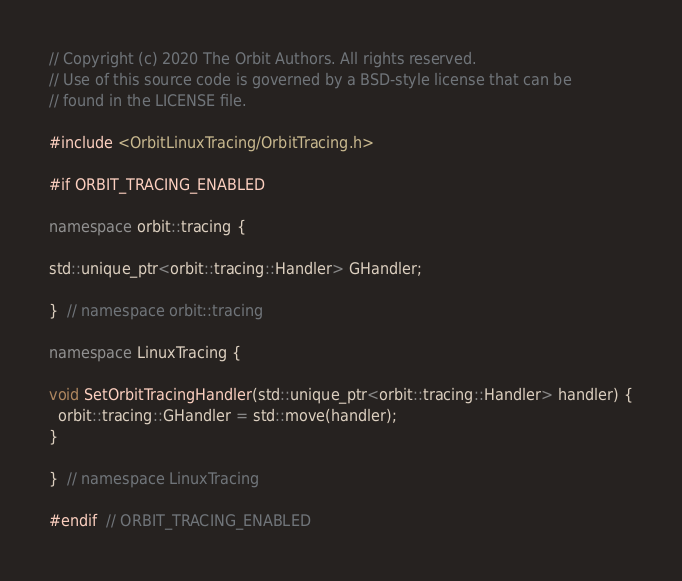<code> <loc_0><loc_0><loc_500><loc_500><_C++_>// Copyright (c) 2020 The Orbit Authors. All rights reserved.
// Use of this source code is governed by a BSD-style license that can be
// found in the LICENSE file.

#include <OrbitLinuxTracing/OrbitTracing.h>

#if ORBIT_TRACING_ENABLED

namespace orbit::tracing {

std::unique_ptr<orbit::tracing::Handler> GHandler;

}  // namespace orbit::tracing

namespace LinuxTracing {

void SetOrbitTracingHandler(std::unique_ptr<orbit::tracing::Handler> handler) {
  orbit::tracing::GHandler = std::move(handler);
}

}  // namespace LinuxTracing

#endif  // ORBIT_TRACING_ENABLED
</code> 